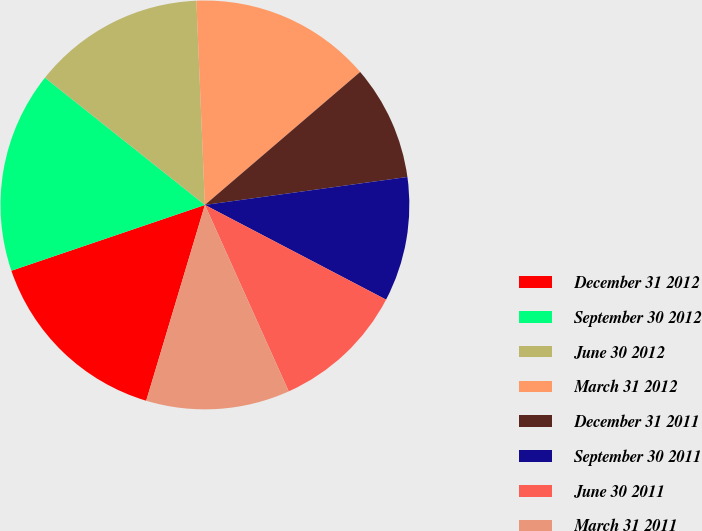<chart> <loc_0><loc_0><loc_500><loc_500><pie_chart><fcel>December 31 2012<fcel>September 30 2012<fcel>June 30 2012<fcel>March 31 2012<fcel>December 31 2011<fcel>September 30 2011<fcel>June 30 2011<fcel>March 31 2011<nl><fcel>15.15%<fcel>15.91%<fcel>13.64%<fcel>14.39%<fcel>9.09%<fcel>9.85%<fcel>10.61%<fcel>11.36%<nl></chart> 